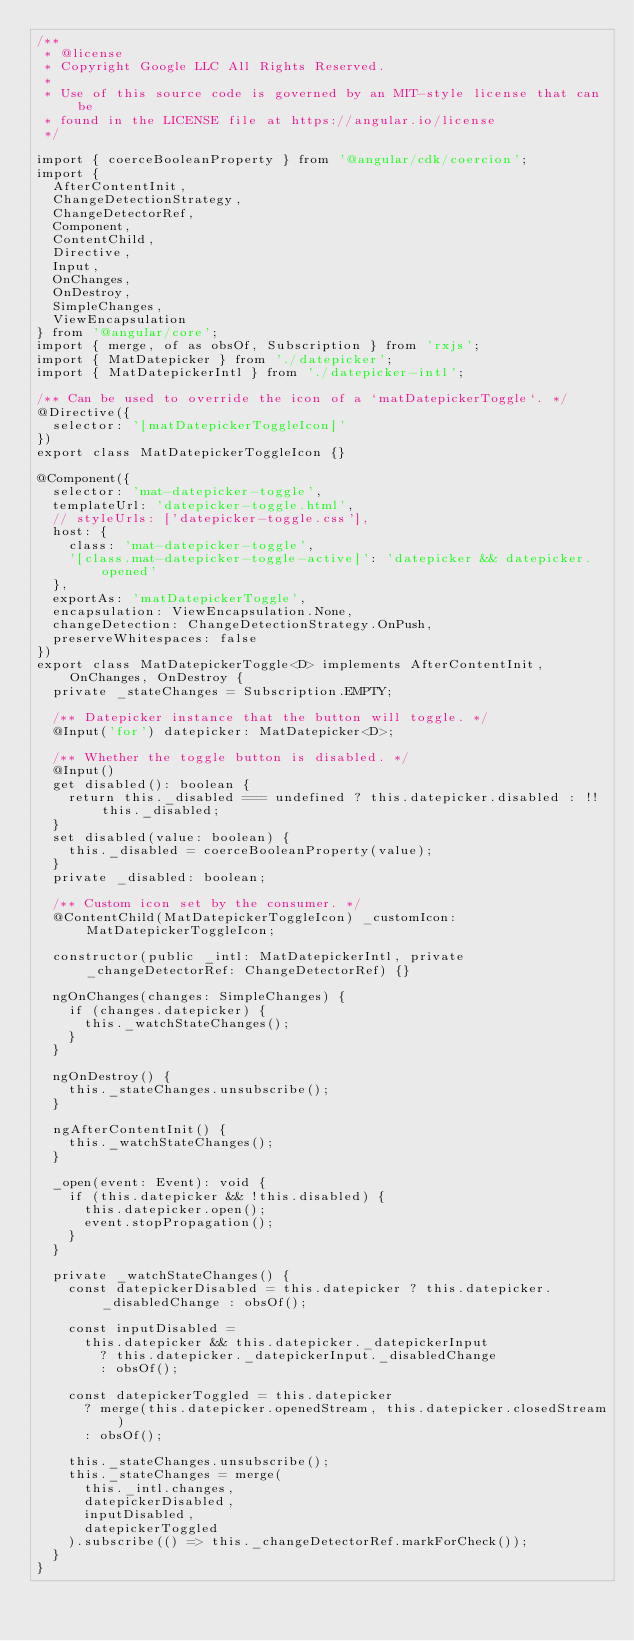Convert code to text. <code><loc_0><loc_0><loc_500><loc_500><_TypeScript_>/**
 * @license
 * Copyright Google LLC All Rights Reserved.
 *
 * Use of this source code is governed by an MIT-style license that can be
 * found in the LICENSE file at https://angular.io/license
 */

import { coerceBooleanProperty } from '@angular/cdk/coercion';
import {
  AfterContentInit,
  ChangeDetectionStrategy,
  ChangeDetectorRef,
  Component,
  ContentChild,
  Directive,
  Input,
  OnChanges,
  OnDestroy,
  SimpleChanges,
  ViewEncapsulation
} from '@angular/core';
import { merge, of as obsOf, Subscription } from 'rxjs';
import { MatDatepicker } from './datepicker';
import { MatDatepickerIntl } from './datepicker-intl';

/** Can be used to override the icon of a `matDatepickerToggle`. */
@Directive({
  selector: '[matDatepickerToggleIcon]'
})
export class MatDatepickerToggleIcon {}

@Component({
  selector: 'mat-datepicker-toggle',
  templateUrl: 'datepicker-toggle.html',
  // styleUrls: ['datepicker-toggle.css'],
  host: {
    class: 'mat-datepicker-toggle',
    '[class.mat-datepicker-toggle-active]': 'datepicker && datepicker.opened'
  },
  exportAs: 'matDatepickerToggle',
  encapsulation: ViewEncapsulation.None,
  changeDetection: ChangeDetectionStrategy.OnPush,
  preserveWhitespaces: false
})
export class MatDatepickerToggle<D> implements AfterContentInit, OnChanges, OnDestroy {
  private _stateChanges = Subscription.EMPTY;

  /** Datepicker instance that the button will toggle. */
  @Input('for') datepicker: MatDatepicker<D>;

  /** Whether the toggle button is disabled. */
  @Input()
  get disabled(): boolean {
    return this._disabled === undefined ? this.datepicker.disabled : !!this._disabled;
  }
  set disabled(value: boolean) {
    this._disabled = coerceBooleanProperty(value);
  }
  private _disabled: boolean;

  /** Custom icon set by the consumer. */
  @ContentChild(MatDatepickerToggleIcon) _customIcon: MatDatepickerToggleIcon;

  constructor(public _intl: MatDatepickerIntl, private _changeDetectorRef: ChangeDetectorRef) {}

  ngOnChanges(changes: SimpleChanges) {
    if (changes.datepicker) {
      this._watchStateChanges();
    }
  }

  ngOnDestroy() {
    this._stateChanges.unsubscribe();
  }

  ngAfterContentInit() {
    this._watchStateChanges();
  }

  _open(event: Event): void {
    if (this.datepicker && !this.disabled) {
      this.datepicker.open();
      event.stopPropagation();
    }
  }

  private _watchStateChanges() {
    const datepickerDisabled = this.datepicker ? this.datepicker._disabledChange : obsOf();

    const inputDisabled =
      this.datepicker && this.datepicker._datepickerInput
        ? this.datepicker._datepickerInput._disabledChange
        : obsOf();

    const datepickerToggled = this.datepicker
      ? merge(this.datepicker.openedStream, this.datepicker.closedStream)
      : obsOf();

    this._stateChanges.unsubscribe();
    this._stateChanges = merge(
      this._intl.changes,
      datepickerDisabled,
      inputDisabled,
      datepickerToggled
    ).subscribe(() => this._changeDetectorRef.markForCheck());
  }
}
</code> 